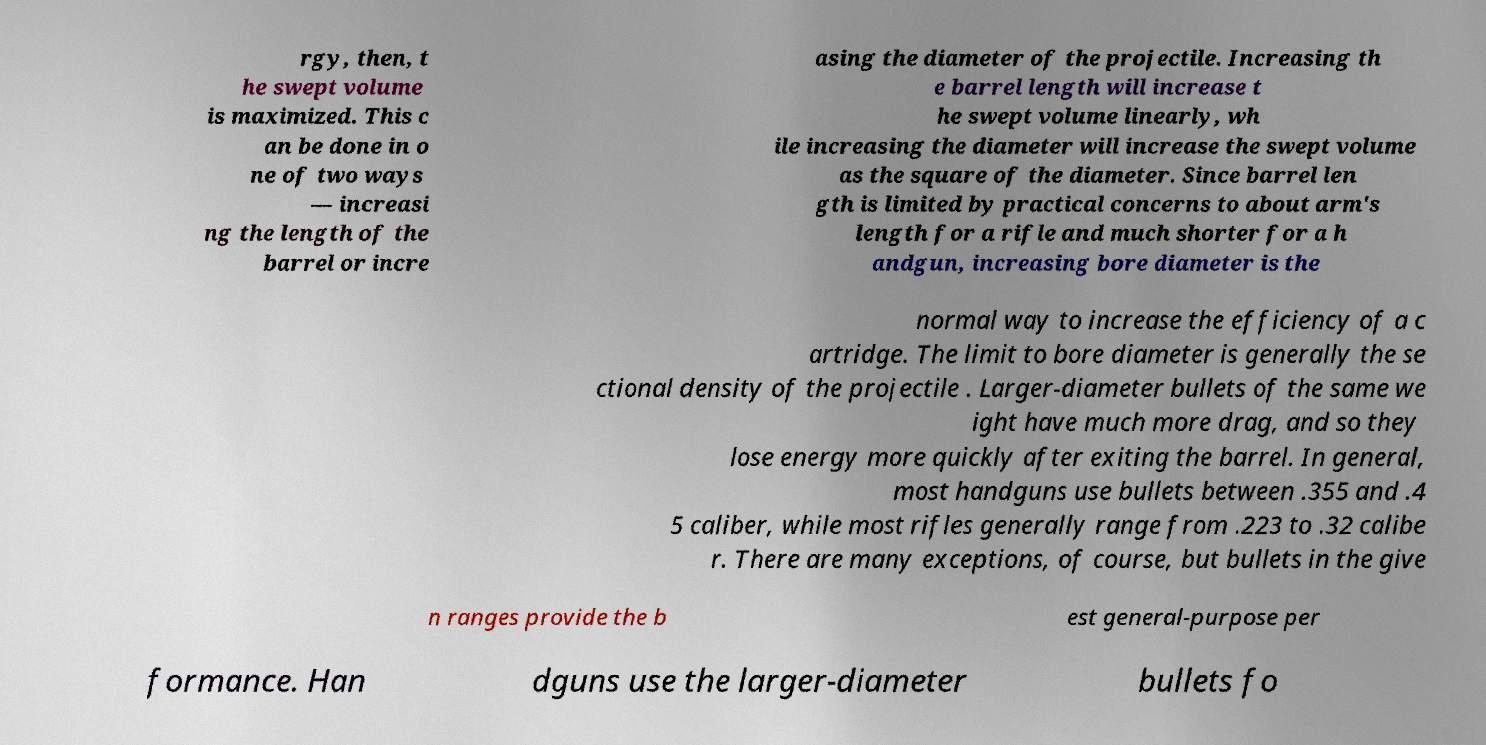Could you assist in decoding the text presented in this image and type it out clearly? rgy, then, t he swept volume is maximized. This c an be done in o ne of two ways — increasi ng the length of the barrel or incre asing the diameter of the projectile. Increasing th e barrel length will increase t he swept volume linearly, wh ile increasing the diameter will increase the swept volume as the square of the diameter. Since barrel len gth is limited by practical concerns to about arm's length for a rifle and much shorter for a h andgun, increasing bore diameter is the normal way to increase the efficiency of a c artridge. The limit to bore diameter is generally the se ctional density of the projectile . Larger-diameter bullets of the same we ight have much more drag, and so they lose energy more quickly after exiting the barrel. In general, most handguns use bullets between .355 and .4 5 caliber, while most rifles generally range from .223 to .32 calibe r. There are many exceptions, of course, but bullets in the give n ranges provide the b est general-purpose per formance. Han dguns use the larger-diameter bullets fo 